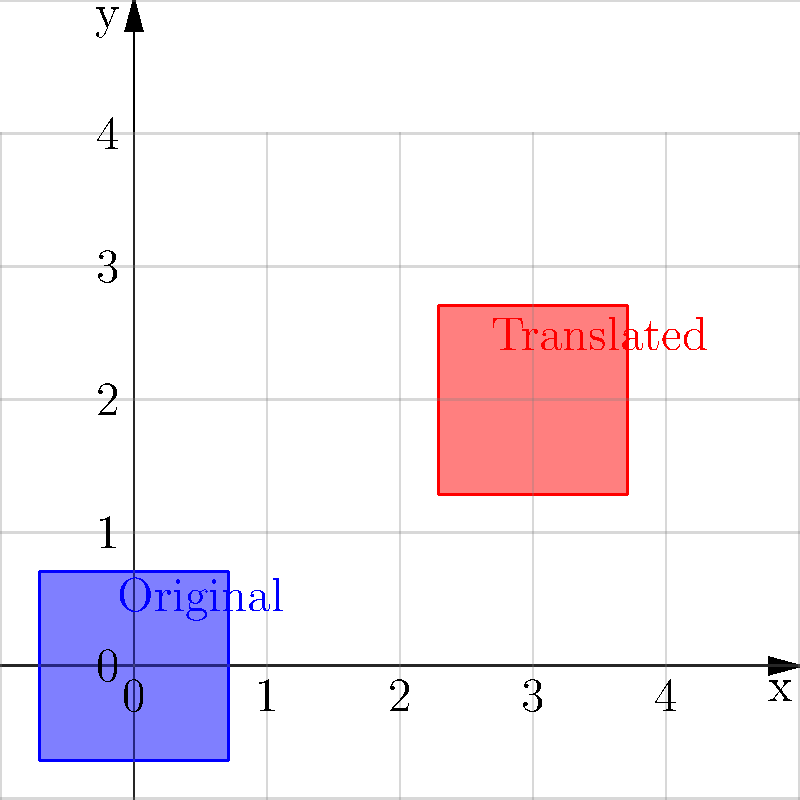In Bellmore, NY, a square representing voter turnout percentages for different elections has been translated on a coordinate plane. If the original square had its bottom-left vertex at $(0,0)$ and the translated square now has its bottom-left vertex at $(3,2)$, what is the translation vector that was applied? To find the translation vector, we need to follow these steps:

1. Identify the original position: The bottom-left vertex of the original square was at $(0,0)$.

2. Identify the new position: The bottom-left vertex of the translated square is at $(3,2)$.

3. Calculate the displacement:
   - x-displacement: $3 - 0 = 3$
   - y-displacement: $2 - 0 = 2$

4. Express the translation as a vector:
   The translation vector is represented by the displacement in both x and y directions.

Therefore, the translation vector is $\langle 3, 2 \rangle$.

This vector indicates that the square representing voter turnout percentages has been moved 3 units to the right and 2 units up from its original position.
Answer: $\langle 3, 2 \rangle$ 